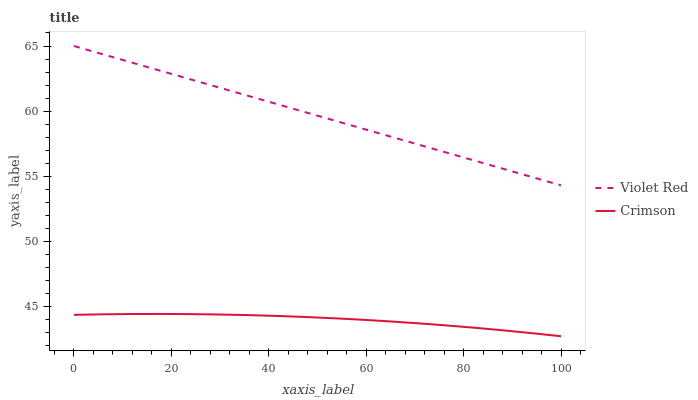Does Violet Red have the minimum area under the curve?
Answer yes or no. No. Is Violet Red the roughest?
Answer yes or no. No. Does Violet Red have the lowest value?
Answer yes or no. No. Is Crimson less than Violet Red?
Answer yes or no. Yes. Is Violet Red greater than Crimson?
Answer yes or no. Yes. Does Crimson intersect Violet Red?
Answer yes or no. No. 